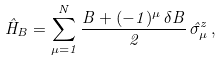Convert formula to latex. <formula><loc_0><loc_0><loc_500><loc_500>\hat { H } _ { B } = \sum _ { \mu = 1 } ^ { N } \frac { B + ( - 1 ) ^ { \mu } \, \delta B } { 2 } \, \hat { \sigma } _ { \mu } ^ { z } \, ,</formula> 